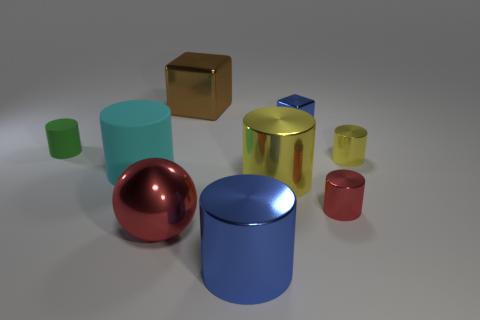Subtract all matte cylinders. How many cylinders are left? 4 Subtract all green cylinders. How many cylinders are left? 5 Subtract all red cylinders. Subtract all purple spheres. How many cylinders are left? 5 Add 1 small blue metallic things. How many objects exist? 10 Subtract all cylinders. How many objects are left? 3 Add 8 big yellow cylinders. How many big yellow cylinders exist? 9 Subtract 0 cyan balls. How many objects are left? 9 Subtract all red blocks. Subtract all big cyan rubber objects. How many objects are left? 8 Add 3 cyan matte cylinders. How many cyan matte cylinders are left? 4 